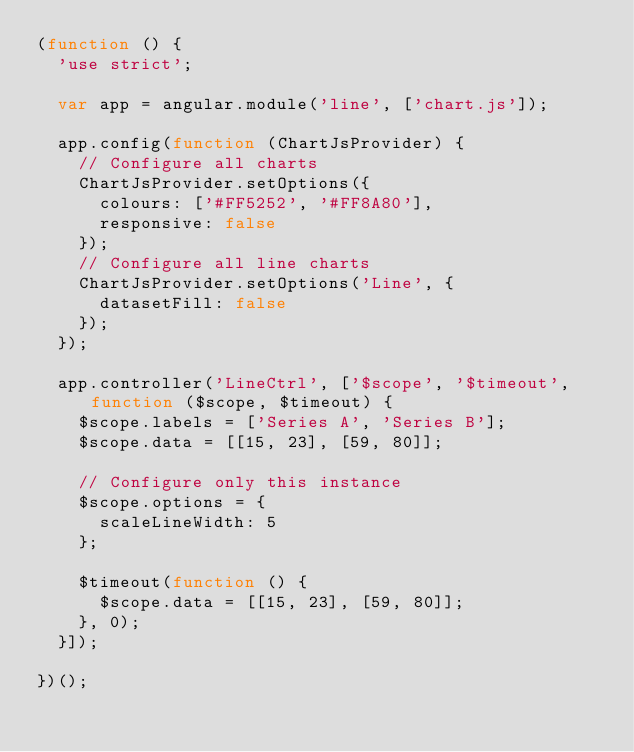<code> <loc_0><loc_0><loc_500><loc_500><_JavaScript_>(function () {
  'use strict';

  var app = angular.module('line', ['chart.js']);

  app.config(function (ChartJsProvider) {
    // Configure all charts
    ChartJsProvider.setOptions({
      colours: ['#FF5252', '#FF8A80'],
      responsive: false
    });
    // Configure all line charts
    ChartJsProvider.setOptions('Line', {
      datasetFill: false
    });
  });

  app.controller('LineCtrl', ['$scope', '$timeout', function ($scope, $timeout) {
    $scope.labels = ['Series A', 'Series B'];
    $scope.data = [[15, 23], [59, 80]];

    // Configure only this instance
    $scope.options = {
      scaleLineWidth: 5
    };

    $timeout(function () {
      $scope.data = [[15, 23], [59, 80]];
    }, 0);
  }]);

})();
</code> 